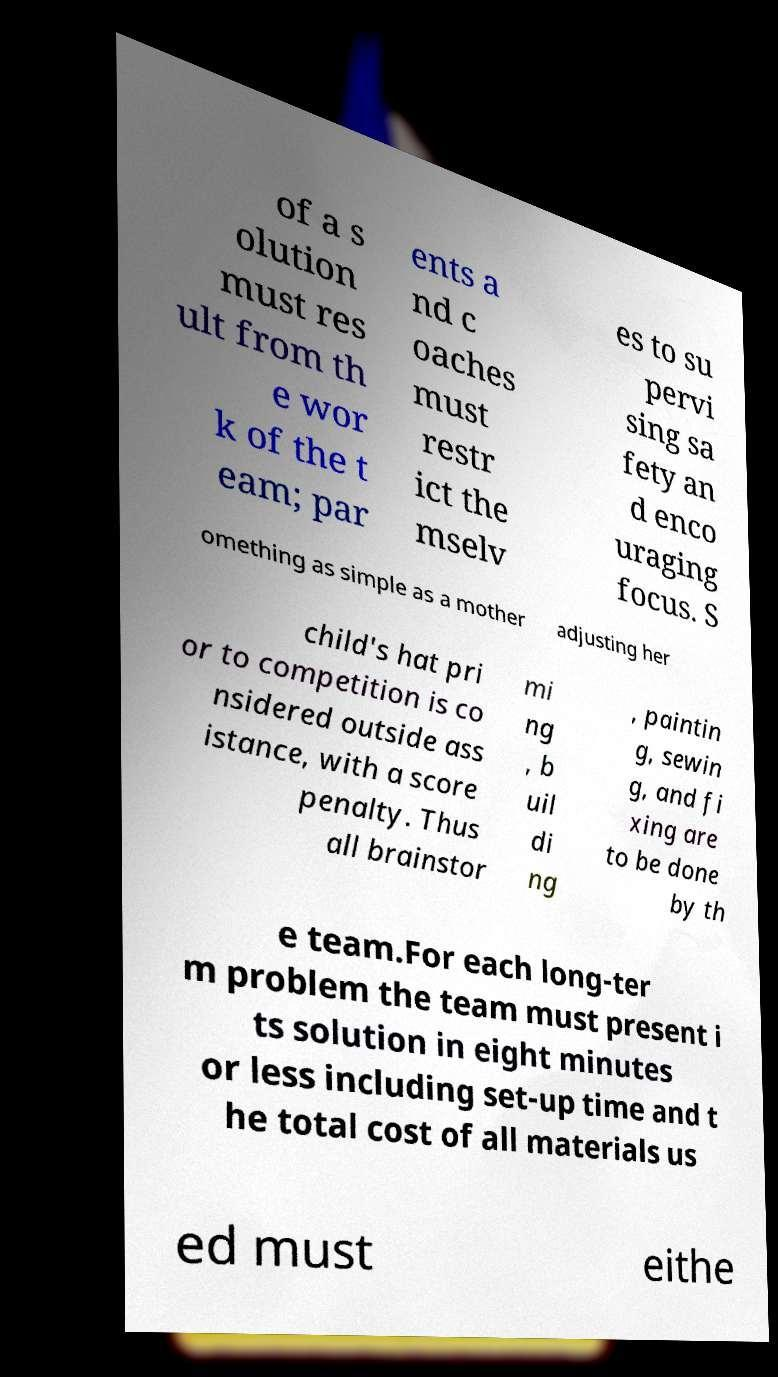I need the written content from this picture converted into text. Can you do that? of a s olution must res ult from th e wor k of the t eam; par ents a nd c oaches must restr ict the mselv es to su pervi sing sa fety an d enco uraging focus. S omething as simple as a mother adjusting her child's hat pri or to competition is co nsidered outside ass istance, with a score penalty. Thus all brainstor mi ng , b uil di ng , paintin g, sewin g, and fi xing are to be done by th e team.For each long-ter m problem the team must present i ts solution in eight minutes or less including set-up time and t he total cost of all materials us ed must eithe 